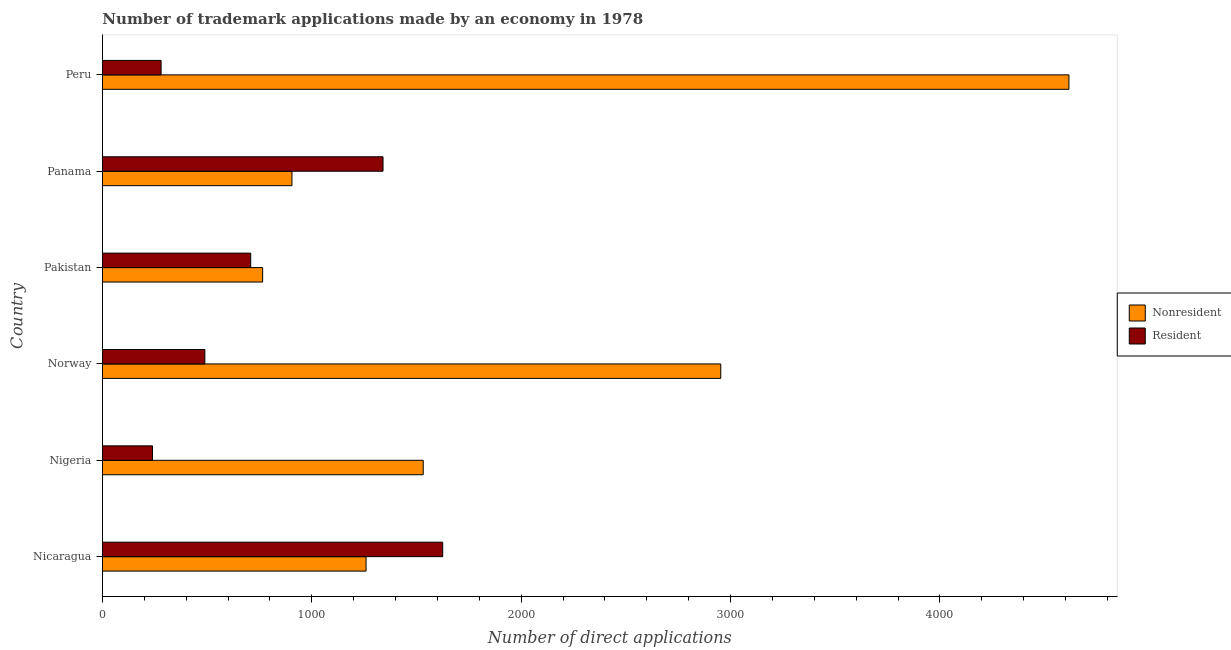How many groups of bars are there?
Your answer should be compact. 6. Are the number of bars per tick equal to the number of legend labels?
Your response must be concise. Yes. How many bars are there on the 2nd tick from the top?
Make the answer very short. 2. What is the label of the 6th group of bars from the top?
Ensure brevity in your answer.  Nicaragua. What is the number of trademark applications made by residents in Pakistan?
Provide a short and direct response. 708. Across all countries, what is the maximum number of trademark applications made by residents?
Offer a terse response. 1625. Across all countries, what is the minimum number of trademark applications made by residents?
Provide a succinct answer. 239. In which country was the number of trademark applications made by non residents maximum?
Offer a very short reply. Peru. In which country was the number of trademark applications made by residents minimum?
Offer a terse response. Nigeria. What is the total number of trademark applications made by non residents in the graph?
Provide a short and direct response. 1.20e+04. What is the difference between the number of trademark applications made by residents in Nigeria and that in Norway?
Ensure brevity in your answer.  -250. What is the difference between the number of trademark applications made by residents in Nigeria and the number of trademark applications made by non residents in Nicaragua?
Ensure brevity in your answer.  -1020. What is the average number of trademark applications made by residents per country?
Your answer should be very brief. 780.17. What is the difference between the number of trademark applications made by residents and number of trademark applications made by non residents in Peru?
Provide a succinct answer. -4336. What is the ratio of the number of trademark applications made by non residents in Nicaragua to that in Pakistan?
Your answer should be very brief. 1.65. Is the number of trademark applications made by non residents in Norway less than that in Pakistan?
Your answer should be compact. No. Is the difference between the number of trademark applications made by non residents in Nicaragua and Panama greater than the difference between the number of trademark applications made by residents in Nicaragua and Panama?
Keep it short and to the point. Yes. What is the difference between the highest and the second highest number of trademark applications made by non residents?
Ensure brevity in your answer.  1663. What is the difference between the highest and the lowest number of trademark applications made by residents?
Make the answer very short. 1386. What does the 2nd bar from the top in Pakistan represents?
Give a very brief answer. Nonresident. What does the 1st bar from the bottom in Peru represents?
Keep it short and to the point. Nonresident. How many bars are there?
Your response must be concise. 12. Does the graph contain grids?
Make the answer very short. No. Where does the legend appear in the graph?
Give a very brief answer. Center right. How are the legend labels stacked?
Your response must be concise. Vertical. What is the title of the graph?
Ensure brevity in your answer.  Number of trademark applications made by an economy in 1978. What is the label or title of the X-axis?
Offer a very short reply. Number of direct applications. What is the Number of direct applications of Nonresident in Nicaragua?
Your answer should be compact. 1259. What is the Number of direct applications of Resident in Nicaragua?
Ensure brevity in your answer.  1625. What is the Number of direct applications in Nonresident in Nigeria?
Ensure brevity in your answer.  1532. What is the Number of direct applications in Resident in Nigeria?
Ensure brevity in your answer.  239. What is the Number of direct applications of Nonresident in Norway?
Offer a terse response. 2953. What is the Number of direct applications in Resident in Norway?
Your answer should be very brief. 489. What is the Number of direct applications in Nonresident in Pakistan?
Provide a short and direct response. 765. What is the Number of direct applications of Resident in Pakistan?
Give a very brief answer. 708. What is the Number of direct applications of Nonresident in Panama?
Your response must be concise. 905. What is the Number of direct applications in Resident in Panama?
Make the answer very short. 1340. What is the Number of direct applications of Nonresident in Peru?
Your answer should be compact. 4616. What is the Number of direct applications in Resident in Peru?
Ensure brevity in your answer.  280. Across all countries, what is the maximum Number of direct applications in Nonresident?
Provide a succinct answer. 4616. Across all countries, what is the maximum Number of direct applications of Resident?
Your response must be concise. 1625. Across all countries, what is the minimum Number of direct applications in Nonresident?
Provide a short and direct response. 765. Across all countries, what is the minimum Number of direct applications in Resident?
Ensure brevity in your answer.  239. What is the total Number of direct applications in Nonresident in the graph?
Give a very brief answer. 1.20e+04. What is the total Number of direct applications of Resident in the graph?
Make the answer very short. 4681. What is the difference between the Number of direct applications of Nonresident in Nicaragua and that in Nigeria?
Offer a terse response. -273. What is the difference between the Number of direct applications in Resident in Nicaragua and that in Nigeria?
Keep it short and to the point. 1386. What is the difference between the Number of direct applications in Nonresident in Nicaragua and that in Norway?
Provide a short and direct response. -1694. What is the difference between the Number of direct applications in Resident in Nicaragua and that in Norway?
Make the answer very short. 1136. What is the difference between the Number of direct applications in Nonresident in Nicaragua and that in Pakistan?
Make the answer very short. 494. What is the difference between the Number of direct applications of Resident in Nicaragua and that in Pakistan?
Your response must be concise. 917. What is the difference between the Number of direct applications of Nonresident in Nicaragua and that in Panama?
Your answer should be very brief. 354. What is the difference between the Number of direct applications in Resident in Nicaragua and that in Panama?
Provide a short and direct response. 285. What is the difference between the Number of direct applications in Nonresident in Nicaragua and that in Peru?
Ensure brevity in your answer.  -3357. What is the difference between the Number of direct applications of Resident in Nicaragua and that in Peru?
Make the answer very short. 1345. What is the difference between the Number of direct applications of Nonresident in Nigeria and that in Norway?
Your answer should be compact. -1421. What is the difference between the Number of direct applications in Resident in Nigeria and that in Norway?
Offer a very short reply. -250. What is the difference between the Number of direct applications in Nonresident in Nigeria and that in Pakistan?
Keep it short and to the point. 767. What is the difference between the Number of direct applications of Resident in Nigeria and that in Pakistan?
Offer a terse response. -469. What is the difference between the Number of direct applications of Nonresident in Nigeria and that in Panama?
Provide a short and direct response. 627. What is the difference between the Number of direct applications of Resident in Nigeria and that in Panama?
Provide a succinct answer. -1101. What is the difference between the Number of direct applications of Nonresident in Nigeria and that in Peru?
Give a very brief answer. -3084. What is the difference between the Number of direct applications of Resident in Nigeria and that in Peru?
Make the answer very short. -41. What is the difference between the Number of direct applications in Nonresident in Norway and that in Pakistan?
Give a very brief answer. 2188. What is the difference between the Number of direct applications in Resident in Norway and that in Pakistan?
Make the answer very short. -219. What is the difference between the Number of direct applications of Nonresident in Norway and that in Panama?
Offer a terse response. 2048. What is the difference between the Number of direct applications of Resident in Norway and that in Panama?
Your answer should be very brief. -851. What is the difference between the Number of direct applications in Nonresident in Norway and that in Peru?
Your response must be concise. -1663. What is the difference between the Number of direct applications in Resident in Norway and that in Peru?
Your answer should be compact. 209. What is the difference between the Number of direct applications of Nonresident in Pakistan and that in Panama?
Offer a terse response. -140. What is the difference between the Number of direct applications in Resident in Pakistan and that in Panama?
Your response must be concise. -632. What is the difference between the Number of direct applications in Nonresident in Pakistan and that in Peru?
Keep it short and to the point. -3851. What is the difference between the Number of direct applications of Resident in Pakistan and that in Peru?
Your answer should be compact. 428. What is the difference between the Number of direct applications of Nonresident in Panama and that in Peru?
Offer a very short reply. -3711. What is the difference between the Number of direct applications of Resident in Panama and that in Peru?
Provide a succinct answer. 1060. What is the difference between the Number of direct applications of Nonresident in Nicaragua and the Number of direct applications of Resident in Nigeria?
Offer a very short reply. 1020. What is the difference between the Number of direct applications in Nonresident in Nicaragua and the Number of direct applications in Resident in Norway?
Offer a very short reply. 770. What is the difference between the Number of direct applications of Nonresident in Nicaragua and the Number of direct applications of Resident in Pakistan?
Your response must be concise. 551. What is the difference between the Number of direct applications in Nonresident in Nicaragua and the Number of direct applications in Resident in Panama?
Provide a short and direct response. -81. What is the difference between the Number of direct applications in Nonresident in Nicaragua and the Number of direct applications in Resident in Peru?
Provide a succinct answer. 979. What is the difference between the Number of direct applications in Nonresident in Nigeria and the Number of direct applications in Resident in Norway?
Keep it short and to the point. 1043. What is the difference between the Number of direct applications in Nonresident in Nigeria and the Number of direct applications in Resident in Pakistan?
Offer a very short reply. 824. What is the difference between the Number of direct applications in Nonresident in Nigeria and the Number of direct applications in Resident in Panama?
Provide a short and direct response. 192. What is the difference between the Number of direct applications in Nonresident in Nigeria and the Number of direct applications in Resident in Peru?
Your answer should be compact. 1252. What is the difference between the Number of direct applications of Nonresident in Norway and the Number of direct applications of Resident in Pakistan?
Your answer should be very brief. 2245. What is the difference between the Number of direct applications of Nonresident in Norway and the Number of direct applications of Resident in Panama?
Make the answer very short. 1613. What is the difference between the Number of direct applications in Nonresident in Norway and the Number of direct applications in Resident in Peru?
Give a very brief answer. 2673. What is the difference between the Number of direct applications in Nonresident in Pakistan and the Number of direct applications in Resident in Panama?
Offer a very short reply. -575. What is the difference between the Number of direct applications in Nonresident in Pakistan and the Number of direct applications in Resident in Peru?
Make the answer very short. 485. What is the difference between the Number of direct applications of Nonresident in Panama and the Number of direct applications of Resident in Peru?
Provide a short and direct response. 625. What is the average Number of direct applications of Nonresident per country?
Ensure brevity in your answer.  2005. What is the average Number of direct applications of Resident per country?
Make the answer very short. 780.17. What is the difference between the Number of direct applications in Nonresident and Number of direct applications in Resident in Nicaragua?
Provide a short and direct response. -366. What is the difference between the Number of direct applications in Nonresident and Number of direct applications in Resident in Nigeria?
Offer a terse response. 1293. What is the difference between the Number of direct applications in Nonresident and Number of direct applications in Resident in Norway?
Keep it short and to the point. 2464. What is the difference between the Number of direct applications of Nonresident and Number of direct applications of Resident in Panama?
Your answer should be very brief. -435. What is the difference between the Number of direct applications of Nonresident and Number of direct applications of Resident in Peru?
Provide a succinct answer. 4336. What is the ratio of the Number of direct applications in Nonresident in Nicaragua to that in Nigeria?
Provide a succinct answer. 0.82. What is the ratio of the Number of direct applications of Resident in Nicaragua to that in Nigeria?
Offer a terse response. 6.8. What is the ratio of the Number of direct applications of Nonresident in Nicaragua to that in Norway?
Provide a short and direct response. 0.43. What is the ratio of the Number of direct applications of Resident in Nicaragua to that in Norway?
Offer a very short reply. 3.32. What is the ratio of the Number of direct applications of Nonresident in Nicaragua to that in Pakistan?
Keep it short and to the point. 1.65. What is the ratio of the Number of direct applications in Resident in Nicaragua to that in Pakistan?
Give a very brief answer. 2.3. What is the ratio of the Number of direct applications of Nonresident in Nicaragua to that in Panama?
Offer a very short reply. 1.39. What is the ratio of the Number of direct applications in Resident in Nicaragua to that in Panama?
Your response must be concise. 1.21. What is the ratio of the Number of direct applications of Nonresident in Nicaragua to that in Peru?
Keep it short and to the point. 0.27. What is the ratio of the Number of direct applications of Resident in Nicaragua to that in Peru?
Your response must be concise. 5.8. What is the ratio of the Number of direct applications in Nonresident in Nigeria to that in Norway?
Keep it short and to the point. 0.52. What is the ratio of the Number of direct applications of Resident in Nigeria to that in Norway?
Your answer should be compact. 0.49. What is the ratio of the Number of direct applications of Nonresident in Nigeria to that in Pakistan?
Give a very brief answer. 2. What is the ratio of the Number of direct applications in Resident in Nigeria to that in Pakistan?
Your answer should be very brief. 0.34. What is the ratio of the Number of direct applications in Nonresident in Nigeria to that in Panama?
Your response must be concise. 1.69. What is the ratio of the Number of direct applications of Resident in Nigeria to that in Panama?
Your response must be concise. 0.18. What is the ratio of the Number of direct applications of Nonresident in Nigeria to that in Peru?
Your answer should be very brief. 0.33. What is the ratio of the Number of direct applications in Resident in Nigeria to that in Peru?
Make the answer very short. 0.85. What is the ratio of the Number of direct applications in Nonresident in Norway to that in Pakistan?
Make the answer very short. 3.86. What is the ratio of the Number of direct applications of Resident in Norway to that in Pakistan?
Ensure brevity in your answer.  0.69. What is the ratio of the Number of direct applications in Nonresident in Norway to that in Panama?
Your answer should be very brief. 3.26. What is the ratio of the Number of direct applications of Resident in Norway to that in Panama?
Keep it short and to the point. 0.36. What is the ratio of the Number of direct applications in Nonresident in Norway to that in Peru?
Ensure brevity in your answer.  0.64. What is the ratio of the Number of direct applications of Resident in Norway to that in Peru?
Offer a terse response. 1.75. What is the ratio of the Number of direct applications of Nonresident in Pakistan to that in Panama?
Your answer should be compact. 0.85. What is the ratio of the Number of direct applications in Resident in Pakistan to that in Panama?
Your response must be concise. 0.53. What is the ratio of the Number of direct applications of Nonresident in Pakistan to that in Peru?
Your response must be concise. 0.17. What is the ratio of the Number of direct applications of Resident in Pakistan to that in Peru?
Give a very brief answer. 2.53. What is the ratio of the Number of direct applications in Nonresident in Panama to that in Peru?
Provide a succinct answer. 0.2. What is the ratio of the Number of direct applications of Resident in Panama to that in Peru?
Offer a very short reply. 4.79. What is the difference between the highest and the second highest Number of direct applications in Nonresident?
Make the answer very short. 1663. What is the difference between the highest and the second highest Number of direct applications in Resident?
Your response must be concise. 285. What is the difference between the highest and the lowest Number of direct applications of Nonresident?
Ensure brevity in your answer.  3851. What is the difference between the highest and the lowest Number of direct applications in Resident?
Your response must be concise. 1386. 